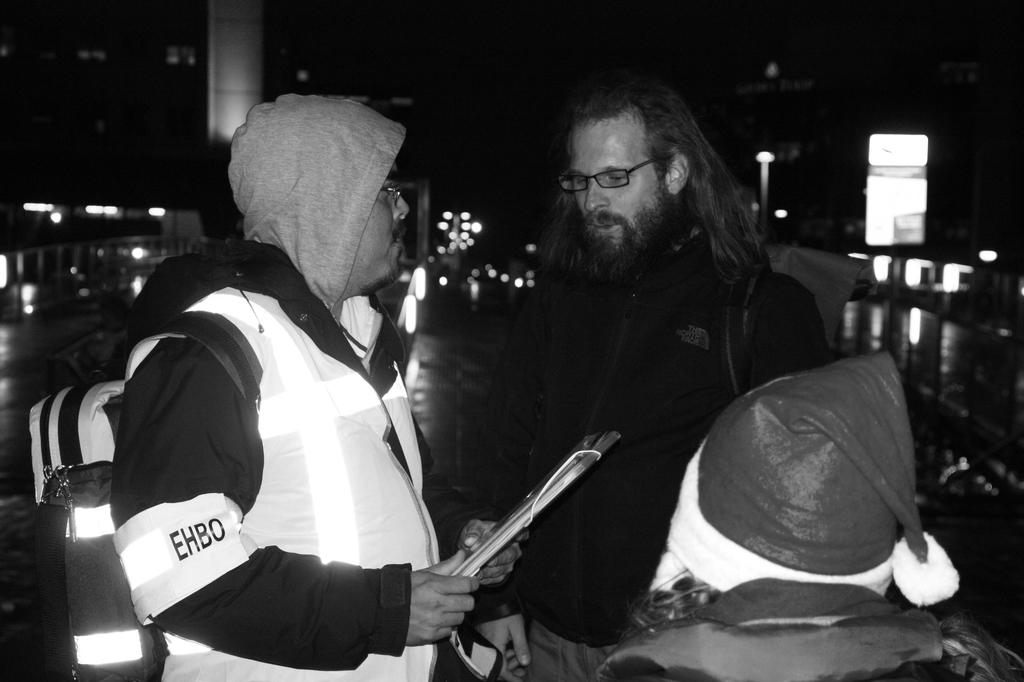How many persons are visible in the image? There are persons standing in the image. Can you describe their position in the image? The persons are standing in the middle of the image. What is the appearance of the person wearing a white dress? The person in the white dress is one of the persons standing in the image. What is the person in the white dress holding? The person in the white dress is holding a file. What type of nut is the judge holding in the image? There is no judge or nut present in the image. What is the person in the white dress using to write on the pen? There is no pen visible in the image, and the person in the white dress is holding a file, not a pen. 